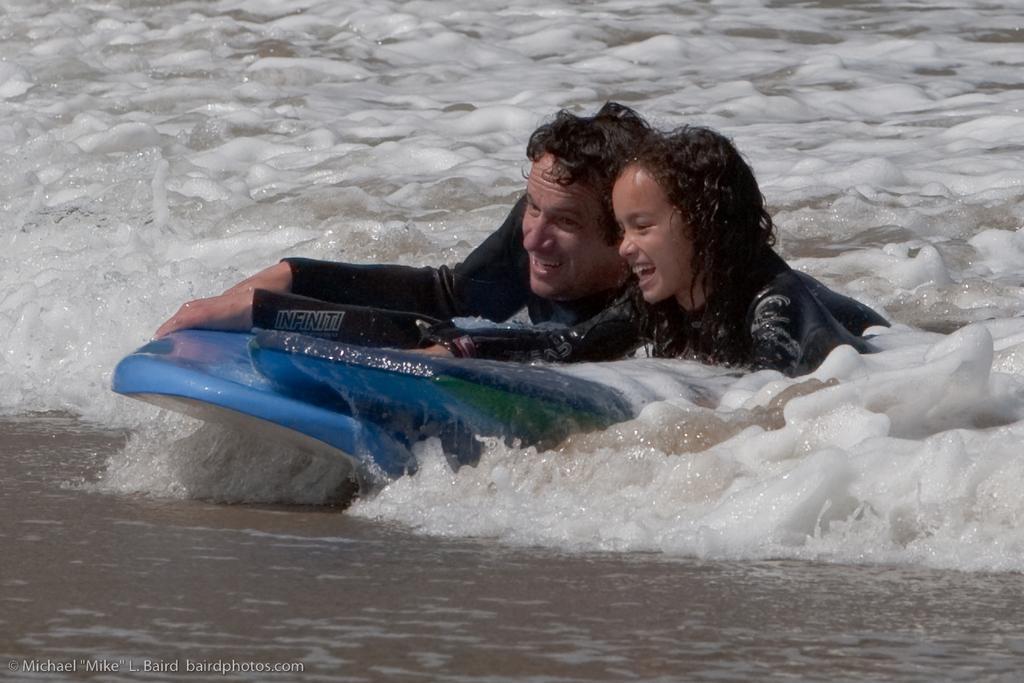Please provide a concise description of this image. This image is taken outdoors. At the bottom of the image there is a ground. In the background there is a sea with waves. In the middle of the image a man and a kid are surfing with a surfing board. 